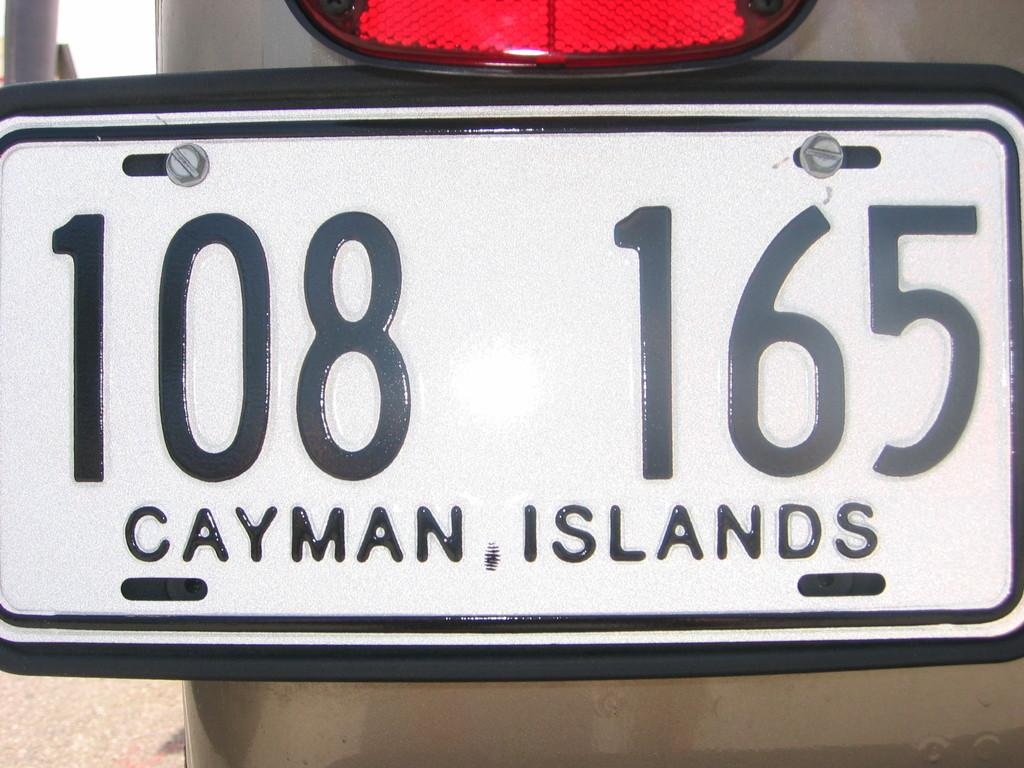What object in the image has a number plate? The number plate belongs to a vehicle in the image. What information can be found on the number plate? There are numbers and text on the number plate. What type of battle is depicted in the image? There is no battle depicted in the image; it only features a number plate with numbers and text. Can you see any jellyfish in the image? There are no jellyfish present in the image. 